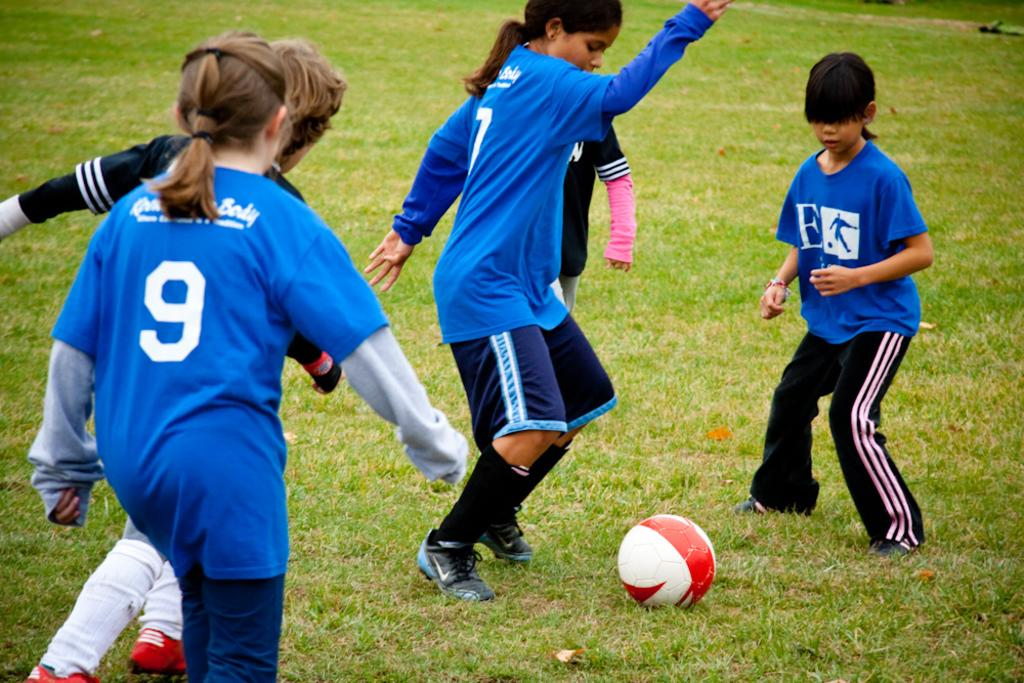How many people are in the image? There is a group of people in the image. What are the people in the image doing? The people are playing a game. What object is involved in the game being played? There is a ball visible in the image. Where is the ball located in the image? The ball is on the grass. What role does the grandfather play in the game being played in the image? There is no mention of a grandfather in the image, so it is impossible to determine any role he might play. 